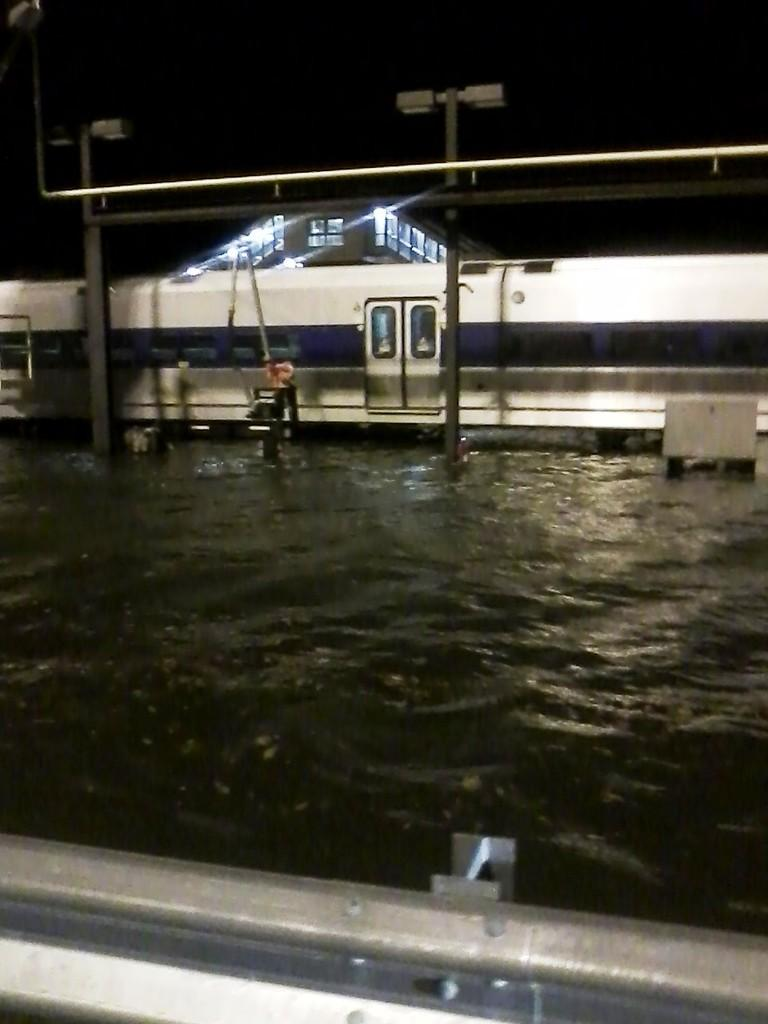What type of structure can be seen in the image? There is a fence in the image. What natural element is visible in the image? There is water visible in the image. What mode of transportation is present in the image? There is a train in the image. What type of lighting is present in the image? There are light poles in the image. What can be seen in the background of the image? There is a building in the background of the image. What type of smell can be detected from the image? There is no information about smells in the image, as it only provides visual information. What type of lunch is being served in the image? There is no information about lunch in the image, as it only provides information about a fence, water, a train, light poles, and a building. 